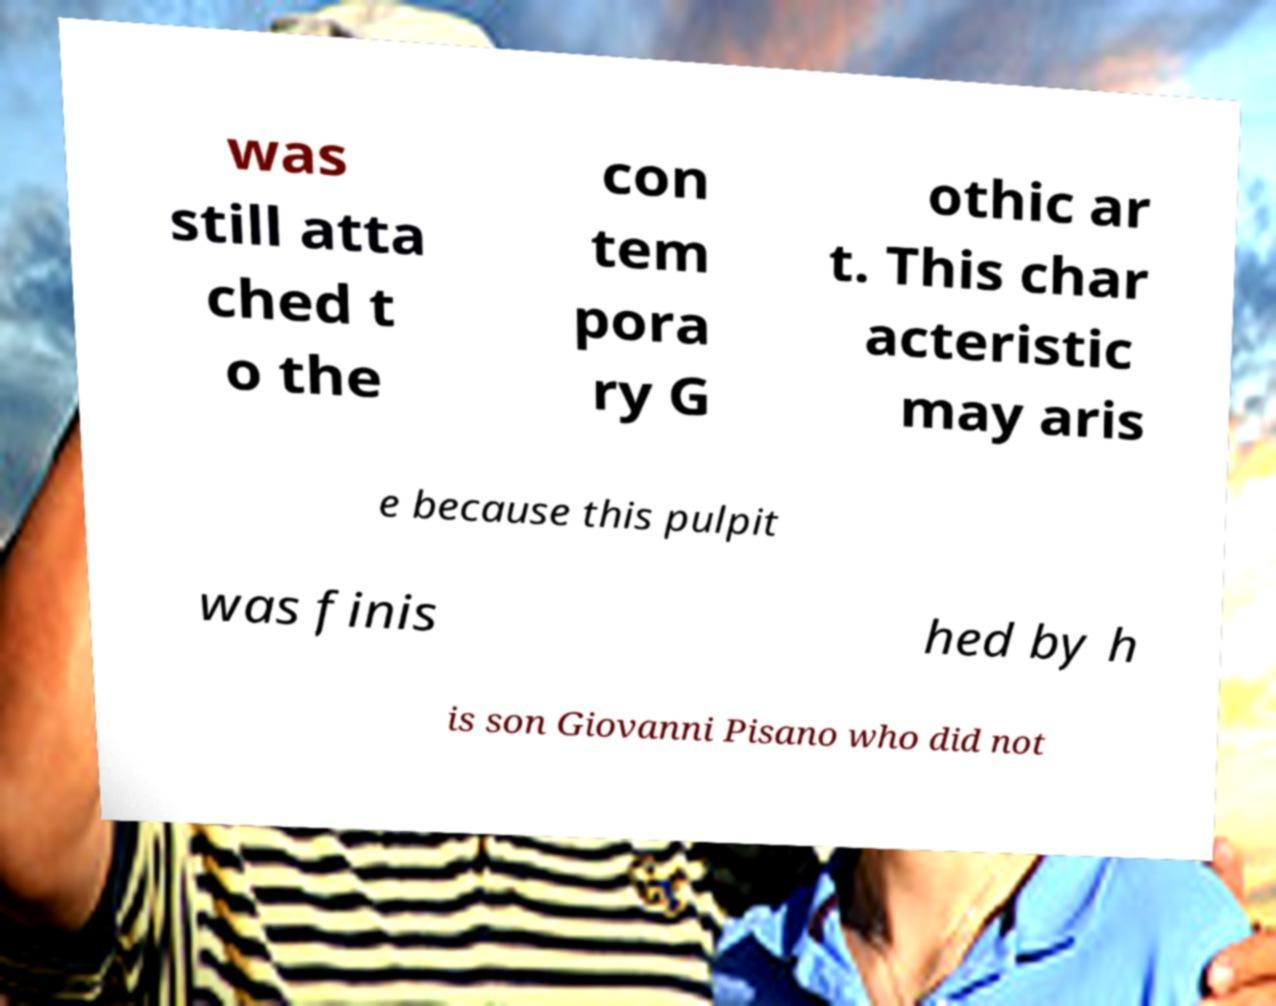Can you read and provide the text displayed in the image?This photo seems to have some interesting text. Can you extract and type it out for me? was still atta ched t o the con tem pora ry G othic ar t. This char acteristic may aris e because this pulpit was finis hed by h is son Giovanni Pisano who did not 